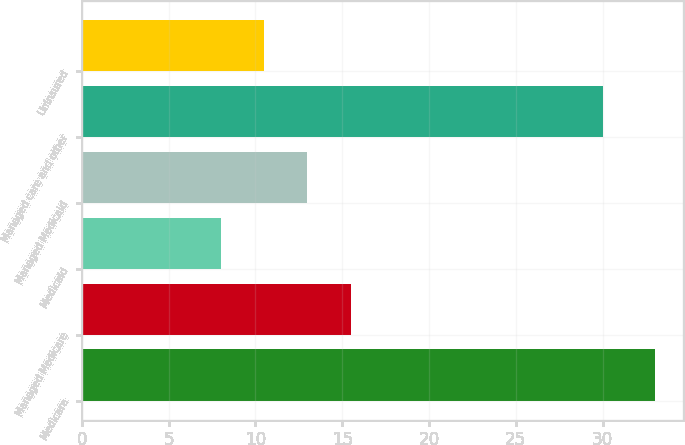Convert chart. <chart><loc_0><loc_0><loc_500><loc_500><bar_chart><fcel>Medicare<fcel>Managed Medicare<fcel>Medicaid<fcel>Managed Medicaid<fcel>Managed care and other<fcel>Uninsured<nl><fcel>33<fcel>15.5<fcel>8<fcel>13<fcel>30<fcel>10.5<nl></chart> 